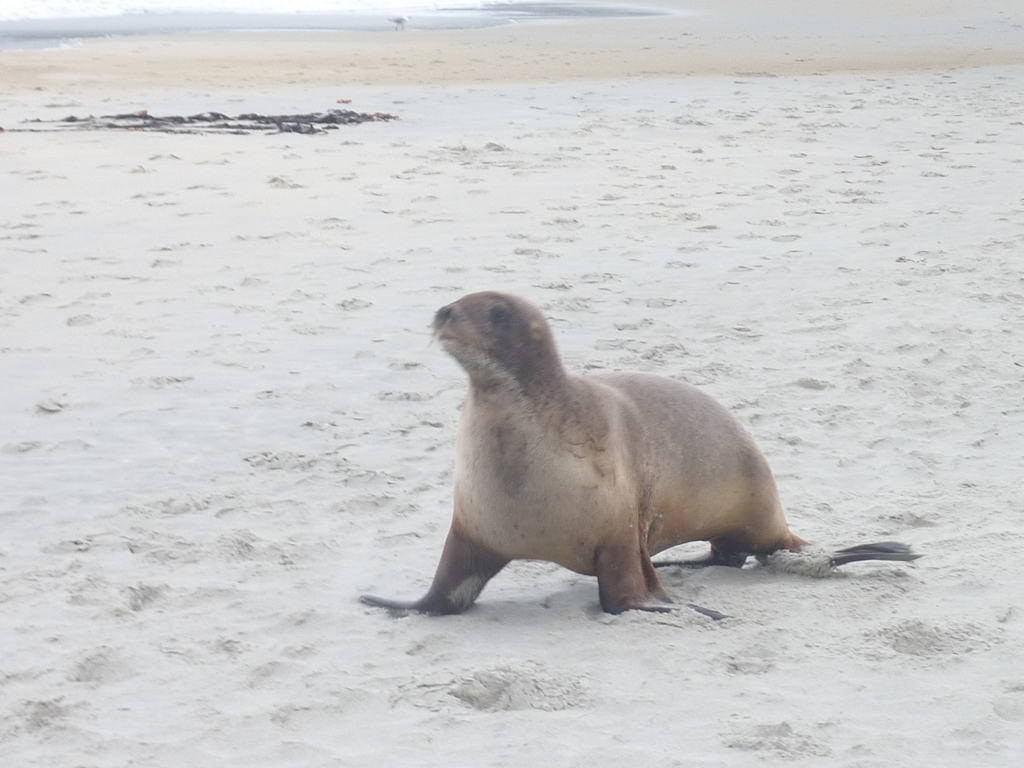Does the seal seem to be interacting with its environment in any particular way? The seal's posture, with its head turned slightly, might indicate it's aware of or reacting to its surroundings. Seals often haul out on beaches to rest, so this one could simply be taking a break from swimming. 